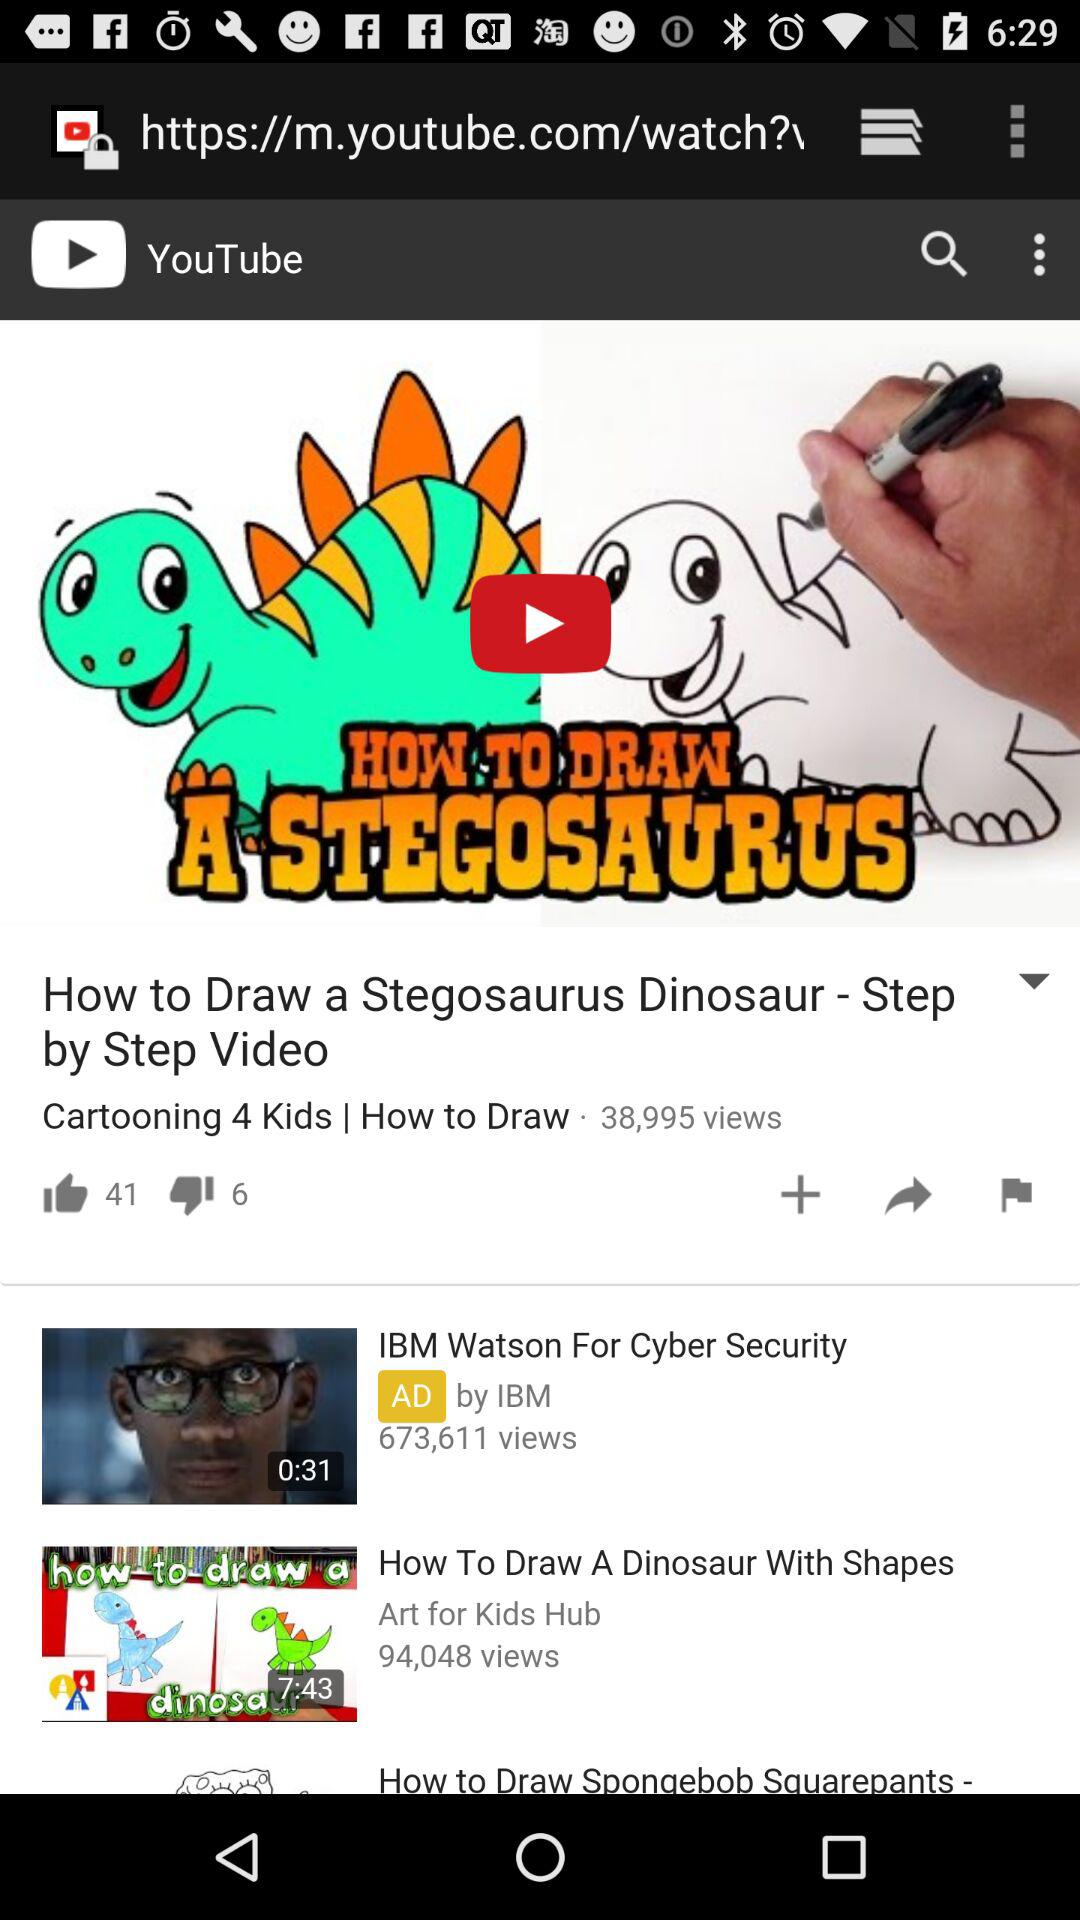How many more thumbs up than down does the first video have?
Answer the question using a single word or phrase. 35 